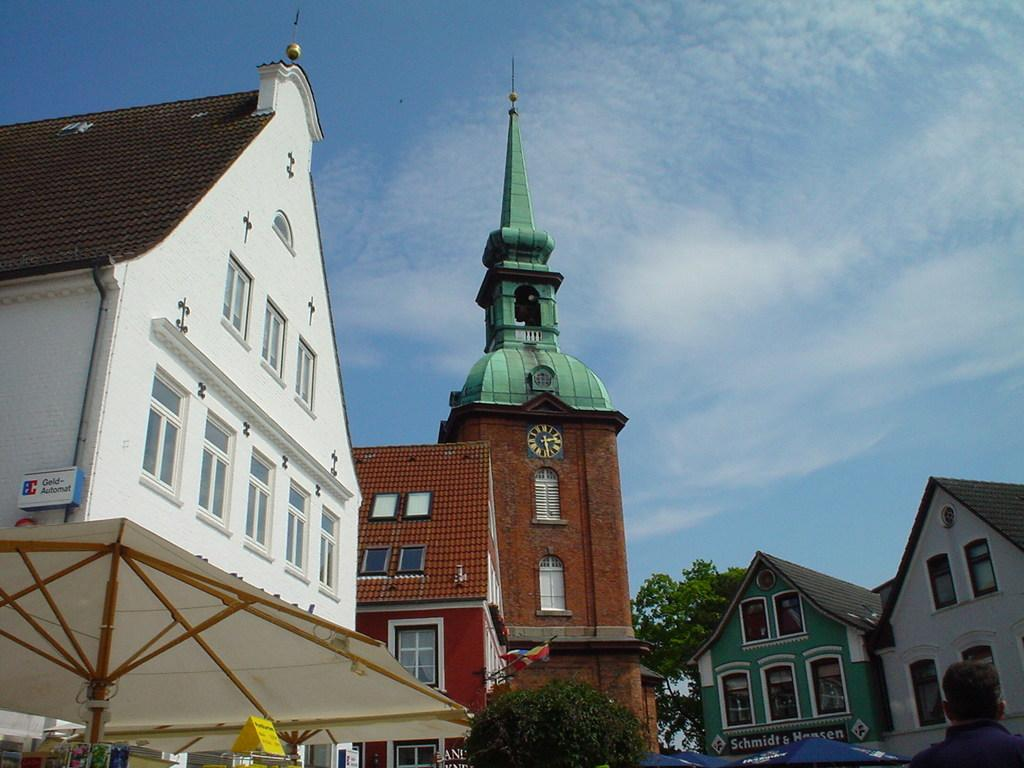What type of structures can be seen in the image? There are buildings in the image. What type of vegetation is present in the image? There are two trees in the image. What is visible in the sky at the top of the image? Clouds are visible in the sky at the top of the image. What type of lace can be seen on the buildings in the image? There is no lace present on the buildings in the image. Can you tell me how many people are swimming in the image? There is no swimming or water present in the image, so it is not possible to determine the number of people swimming. 